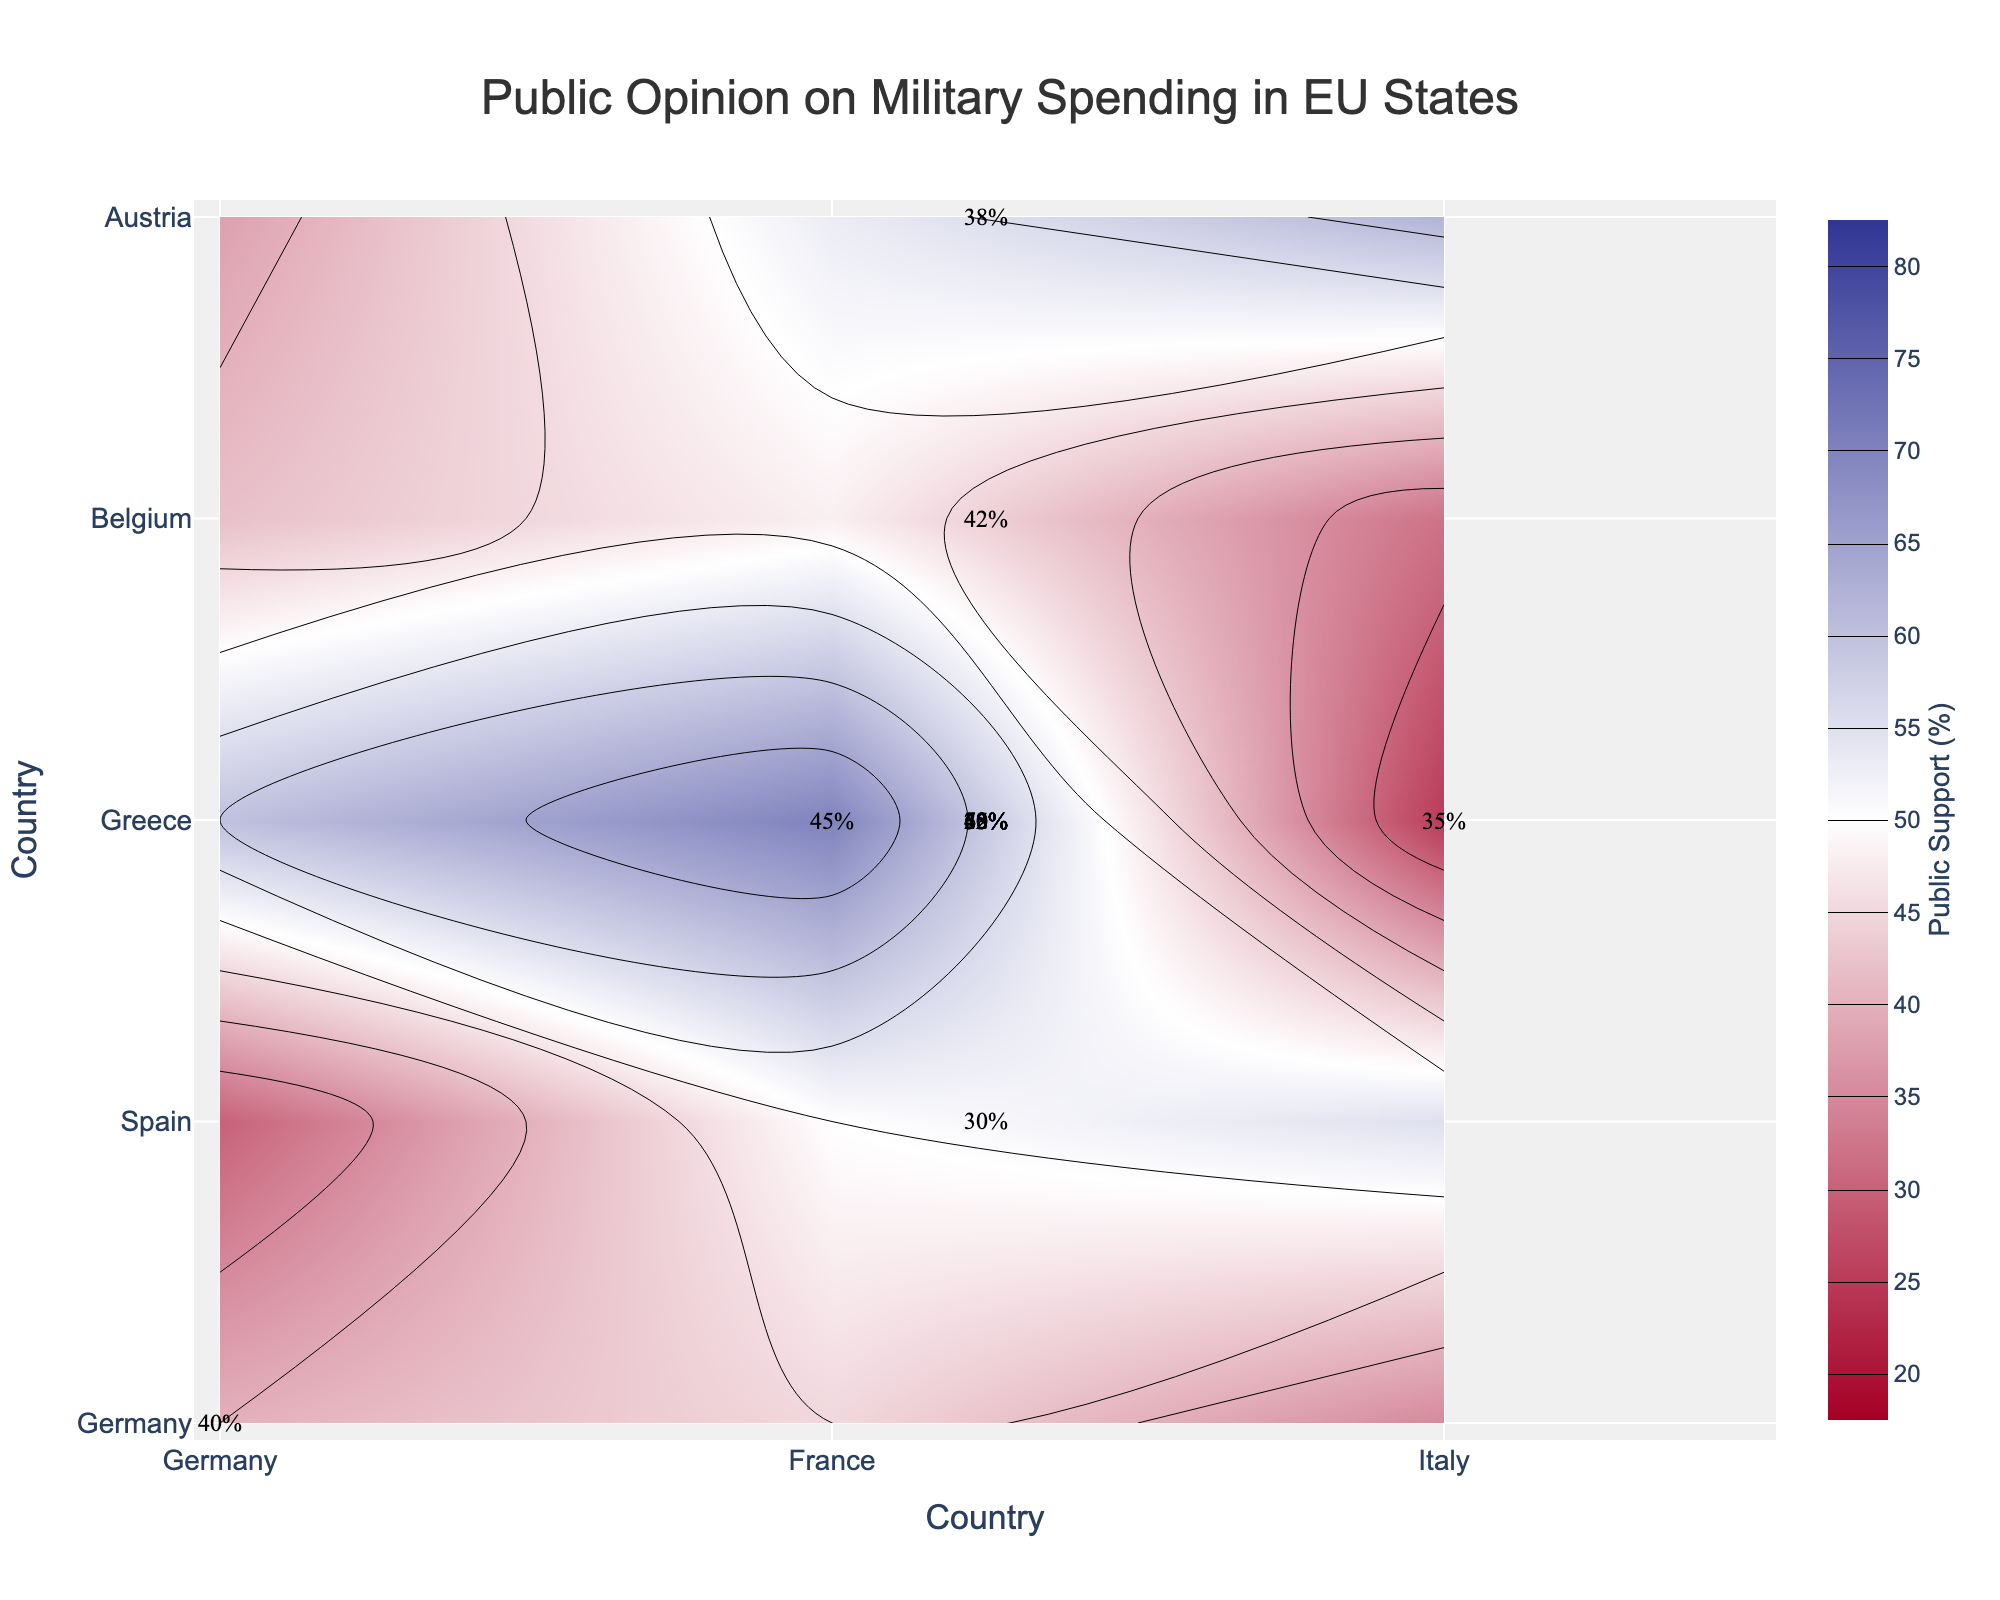What is the title of the plot? The title of the plot is located at the top of the figure. It provides a summary of what the plot visualizes. From the description, the title is "Public Opinion on Military Spending in EU States."
Answer: Public Opinion on Military Spending in EU States Which Country has the highest public support for military spending in 2021? From the contour labels, we can see the different levels of public support. Poland shows the highest percentage of public support for military spending among the listed countries.
Answer: Poland What is the level of public support for military spending in France in 2021? By looking at the contour labels, we can directly see the percentage of public support for each country. France has a public support level of 45%.
Answer: 45% How do Greece and Hungary compare in terms of public support for military spending? By looking at the contour labels for both countries, we see that Greece has 60% support while Hungary has 62% support. Hungary has slightly higher public support for military spending compared to Greece.
Answer: Hungary has higher support Which country has the lowest public support for military spending, and what is the percentage? By examining all the contour labels, Portugal has the lowest public support for military spending, with a percentage of 25%.
Answer: Portugal, 25% What is the average public support for military spending across all listed countries? To find the average, sum all the percentages of public support and divide by the number of countries. The sum is 732 (40 + 45 + 35 + 30 + 50 + 55 + 60 + 70 + 25 + 42 + 48 + 32 + 38 + 53 + 62) and there are 15 countries. Average = 732 / 15 = 48.8%.
Answer: 48.8% How many countries have more than 50% public support for military spending? By reviewing the contour labels, we identify the countries with more than 50% support: Poland (70%), Hungary (62%), Greece (60%), Sweden (55%), and Denmark (53%). There are 5 such countries.
Answer: 5 What is the range of public support percentages among the listed EU countries? The highest percentage is in Poland (70%) and the lowest is in Portugal (25%). The range is the difference between these values: 70 - 25 = 45%.
Answer: 45% Which country has a similar level of public support (within ±2%) to Sweden's public support in 2021? Sweden has 55% public support. Scanning the contour labels for similar values, Denmark has 53% public support, which is within ±2%.
Answer: Denmark 